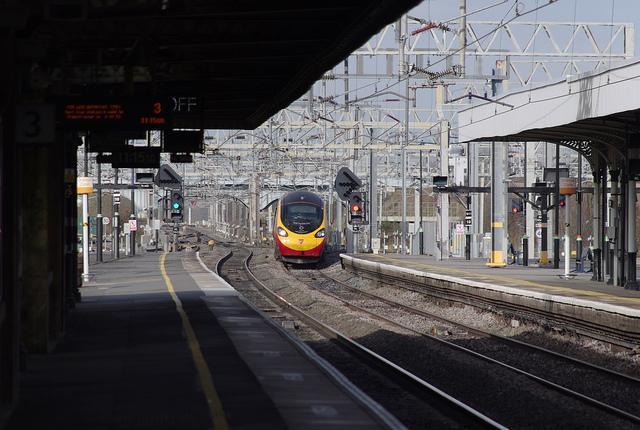How many tracks are seen?
Give a very brief answer. 2. How many trains are seen?
Give a very brief answer. 1. How many trains can be seen?
Give a very brief answer. 1. How many sheep in the pen at the bottom?
Give a very brief answer. 0. 